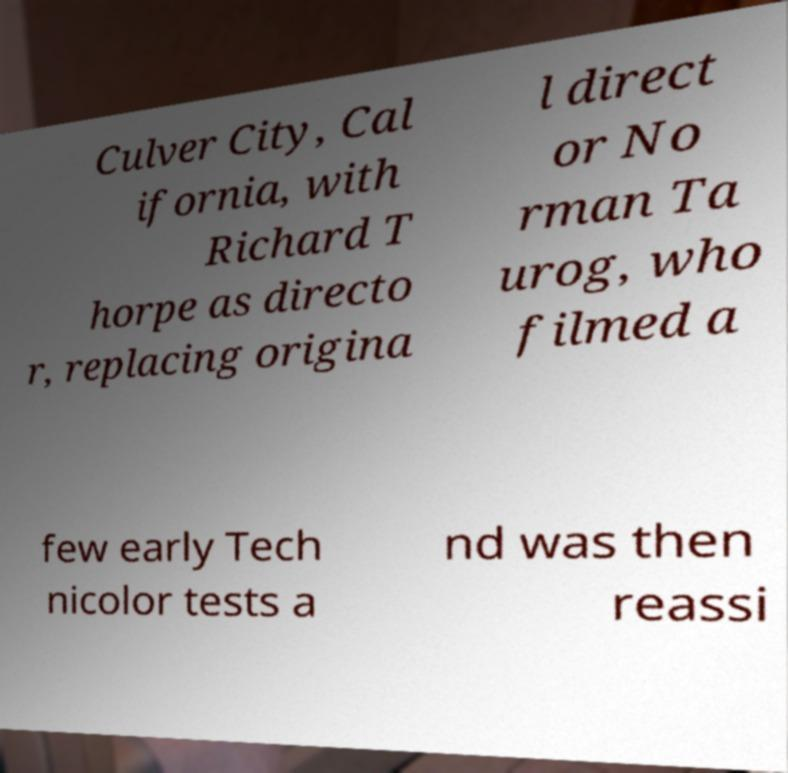I need the written content from this picture converted into text. Can you do that? Culver City, Cal ifornia, with Richard T horpe as directo r, replacing origina l direct or No rman Ta urog, who filmed a few early Tech nicolor tests a nd was then reassi 